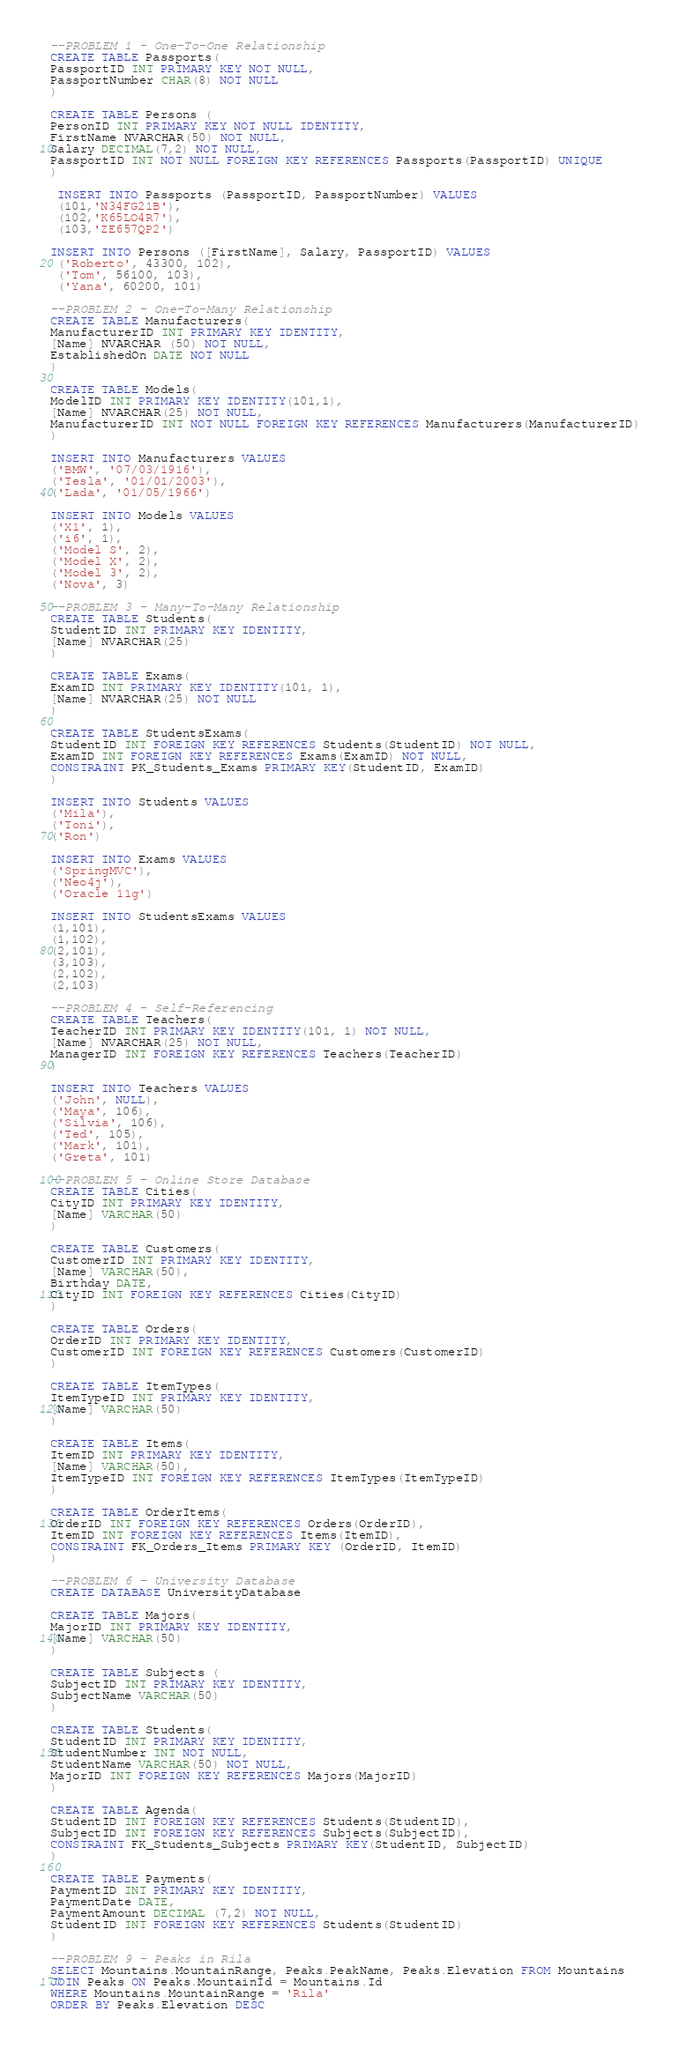<code> <loc_0><loc_0><loc_500><loc_500><_SQL_>--PROBLEM 1 - One-To-One Relationship
CREATE TABLE Passports(
PassportID INT PRIMARY KEY NOT NULL,
PassportNumber CHAR(8) NOT NULL
)

CREATE TABLE Persons (
PersonID INT PRIMARY KEY NOT NULL IDENTITY,
FirstName NVARCHAR(50) NOT NULL,
Salary DECIMAL(7,2) NOT NULL,
PassportID INT NOT NULL FOREIGN KEY REFERENCES Passports(PassportID) UNIQUE
)

 INSERT INTO Passports (PassportID, PassportNumber) VALUES
 (101,'N34FG21B'),
 (102,'K65LO4R7'),
 (103,'ZE657QP2') 

INSERT INTO Persons ([FirstName], Salary, PassportID) VALUES
 ('Roberto', 43300, 102),
 ('Tom', 56100, 103),
 ('Yana', 60200, 101)

--PROBLEM 2 - One-To-Many Relationship
CREATE TABLE Manufacturers(
ManufacturerID INT PRIMARY KEY IDENTITY,
[Name] NVARCHAR (50) NOT NULL,
EstablishedOn DATE NOT NULL
)

CREATE TABLE Models(
ModelID INT PRIMARY KEY IDENTITY(101,1),
[Name] NVARCHAR(25) NOT NULL,
ManufacturerID INT NOT NULL FOREIGN KEY REFERENCES Manufacturers(ManufacturerID)
)

INSERT INTO Manufacturers VALUES
('BMW', '07/03/1916'),
('Tesla', '01/01/2003'),
('Lada', '01/05/1966')

INSERT INTO Models VALUES
('X1', 1),
('i6', 1),
('Model S', 2),
('Model X', 2),
('Model 3', 2),
('Nova', 3)

--PROBLEM 3 - Many-To-Many Relationship
CREATE TABLE Students(
StudentID INT PRIMARY KEY IDENTITY,
[Name] NVARCHAR(25)
)

CREATE TABLE Exams(
ExamID INT PRIMARY KEY IDENTITY(101, 1),
[Name] NVARCHAR(25) NOT NULL
)

CREATE TABLE StudentsExams(
StudentID INT FOREIGN KEY REFERENCES Students(StudentID) NOT NULL,
ExamID INT FOREIGN KEY REFERENCES Exams(ExamID) NOT NULL,
CONSTRAINT PK_Students_Exams PRIMARY KEY(StudentID, ExamID)
)

INSERT INTO Students VALUES
('Mila'),
('Toni'),
('Ron')

INSERT INTO Exams VALUES
('SpringMVC'),
('Neo4j'),
('Oracle 11g')

INSERT INTO StudentsExams VALUES
(1,101),
(1,102),
(2,101),
(3,103),
(2,102),
(2,103)

--PROBLEM 4 - Self-Referencing
CREATE TABLE Teachers(
TeacherID INT PRIMARY KEY IDENTITY(101, 1) NOT NULL,
[Name] NVARCHAR(25) NOT NULL,
ManagerID INT FOREIGN KEY REFERENCES Teachers(TeacherID)
)

INSERT INTO Teachers VALUES
('John', NULL),
('Maya', 106),
('Silvia', 106),
('Ted', 105),
('Mark', 101),
('Greta', 101)

--PROBLEM 5 - Online Store Database
CREATE TABLE Cities(
CityID INT PRIMARY KEY IDENTITY,
[Name] VARCHAR(50)
)

CREATE TABLE Customers(
CustomerID INT PRIMARY KEY IDENTITY,
[Name] VARCHAR(50),
Birthday DATE,
CityID INT FOREIGN KEY REFERENCES Cities(CityID)
)

CREATE TABLE Orders(
OrderID INT PRIMARY KEY IDENTITY,
CustomerID INT FOREIGN KEY REFERENCES Customers(CustomerID)
)

CREATE TABLE ItemTypes(
ItemTypeID INT PRIMARY KEY IDENTITY,
[Name] VARCHAR(50)
)

CREATE TABLE Items(
ItemID INT PRIMARY KEY IDENTITY,
[Name] VARCHAR(50),
ItemTypeID INT FOREIGN KEY REFERENCES ItemTypes(ItemTypeID)
)

CREATE TABLE OrderItems(
OrderID INT FOREIGN KEY REFERENCES Orders(OrderID),
ItemID INT FOREIGN KEY REFERENCES Items(ItemID),
CONSTRAINT FK_Orders_Items PRIMARY KEY (OrderID, ItemID)
)

--PROBLEM 6 - University Database
CREATE DATABASE UniversityDatabase

CREATE TABLE Majors(
MajorID INT PRIMARY KEY IDENTITY,
[Name] VARCHAR(50)
)

CREATE TABLE Subjects (
SubjectID INT PRIMARY KEY IDENTITY,
SubjectName VARCHAR(50)
)

CREATE TABLE Students(
StudentID INT PRIMARY KEY IDENTITY,
StudentNumber INT NOT NULL,
StudentName VARCHAR(50) NOT NULL,
MajorID INT FOREIGN KEY REFERENCES Majors(MajorID)
)

CREATE TABLE Agenda(
StudentID INT FOREIGN KEY REFERENCES Students(StudentID),
SubjectID INT FOREIGN KEY REFERENCES Subjects(SubjectID),
CONSTRAINT FK_Students_Subjects PRIMARY KEY(StudentID, SubjectID)
)
 
CREATE TABLE Payments(
PaymentID INT PRIMARY KEY IDENTITY,
PaymentDate DATE,
PaymentAmount DECIMAL (7,2) NOT NULL,
StudentID INT FOREIGN KEY REFERENCES Students(StudentID)
)

--PROBLEM 9 - Peaks in Rila
SELECT Mountains.MountainRange, Peaks.PeakName, Peaks.Elevation FROM Mountains
JOIN Peaks ON Peaks.MountainId = Mountains.Id
WHERE Mountains.MountainRange = 'Rila'
ORDER BY Peaks.Elevation DESC</code> 